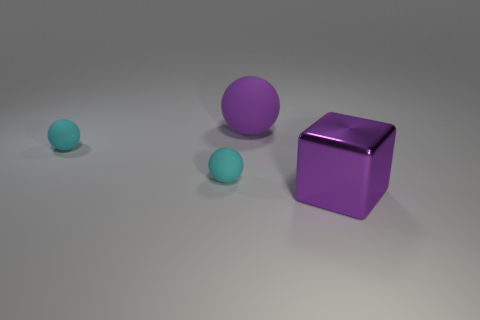Can you describe the positioning of the objects relative to each other? Certainly! The objects are arranged with a noticeable gap between them, each one positioned at a varying distance from the others. To the left are two cyan spheres, with the smaller one being closer to the foreground, creating a sense of depth. The larger purple cube is isolated to the right, dominating its space. 